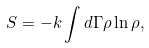<formula> <loc_0><loc_0><loc_500><loc_500>S = - k \int d \Gamma \rho \ln \rho ,</formula> 